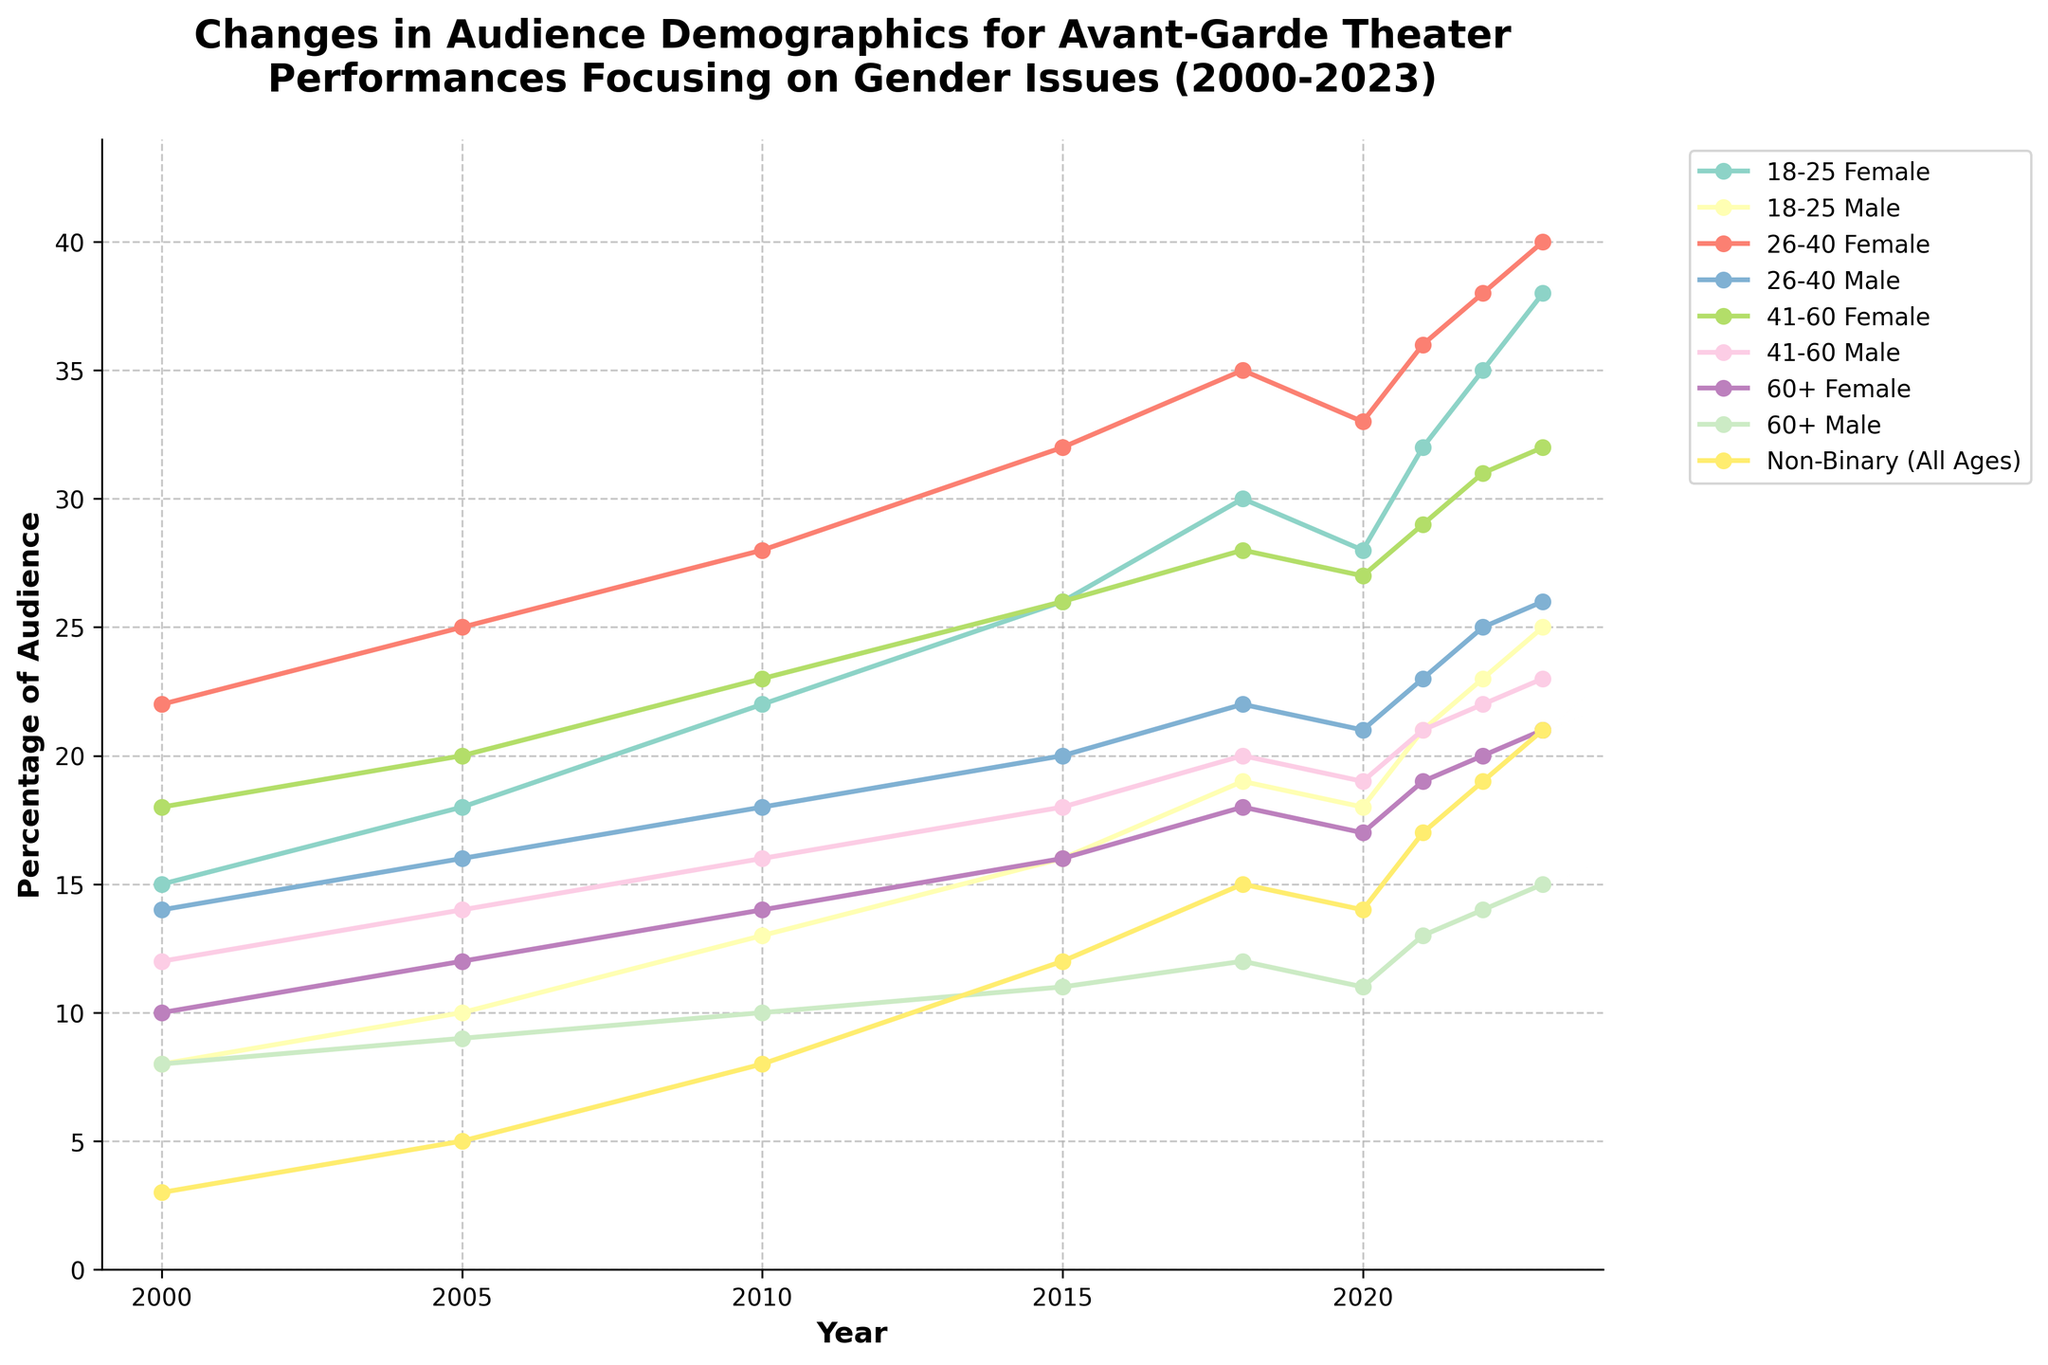What was the percentage increase in the 18-25 Female audience from 2000 to 2023? To find the percentage increase, subtract the initial value in 2000 (15) from the final value in 2023 (38), then divide the difference by the initial value and multiply by 100: \(((38-15)/15)*100\).
Answer: 153.33% In 2023, which age group has the highest percentage among females? By examining the percentages of the female age groups in 2023, it is evident that the 26-40 Female group has the highest percentage at 40.
Answer: 26-40 Female Compare the percentage of 26-40 Male audience in 2020 and 2023. How much has it increased? In 2020, the percentage was 21, and in 2023, it is 26. The increase is calculated by subtracting the earlier value from the later value: \(26-21\).
Answer: 5 Between 2010 and 2021, which demographic group has seen the largest increase in their audience percentage? Calculate the difference for each group between 2021 and 2010, then identify which group has the largest difference. The Non-Binary (All Ages) group increased from 8 in 2010 to 17 in 2021, an increase of 9, which is the largest.
Answer: Non-Binary (All Ages) What is the sum of the percentages for all age groups (including Non-Binary) in 2018? Add the values for all demographics in 2018: \(30 + 19 + 35 + 22 + 28 + 20 + 18 + 12 + 15\).
Answer: 199 Is the percentage of 41-60 Male audience in 2000 greater than or less than the Non-Binary audience in 2023? Compare the percentages: the 41-60 Male audience in 2000 is 12, while the Non-Binary audience in 2023 is 21. 12 is less than 21.
Answer: Less than Which demographic group shows a consistent increase throughout the years from 2000 to 2023? Identify a group that shows an increase in percentage every year. The 18-25 Female demographic consistently increases every year from 2000 (15) to 2023 (38).
Answer: 18-25 Female What is the average percentage of the 60+ Female audience from 2005 to 2015? Sum the values for the 60+ Female audience from 2005 (12), 2010 (14), and 2015 (16), then divide by the number of years: \((12 + 14 + 16)/3\).
Answer: 14 In which year did the Non-Binary audience percentage first exceed 10%? Identify the first year Non-Binary audience exceeded 10%. In 2010, it is 8, in 2015 it is 12, so 2015 is the first year to exceed.
Answer: 2015 